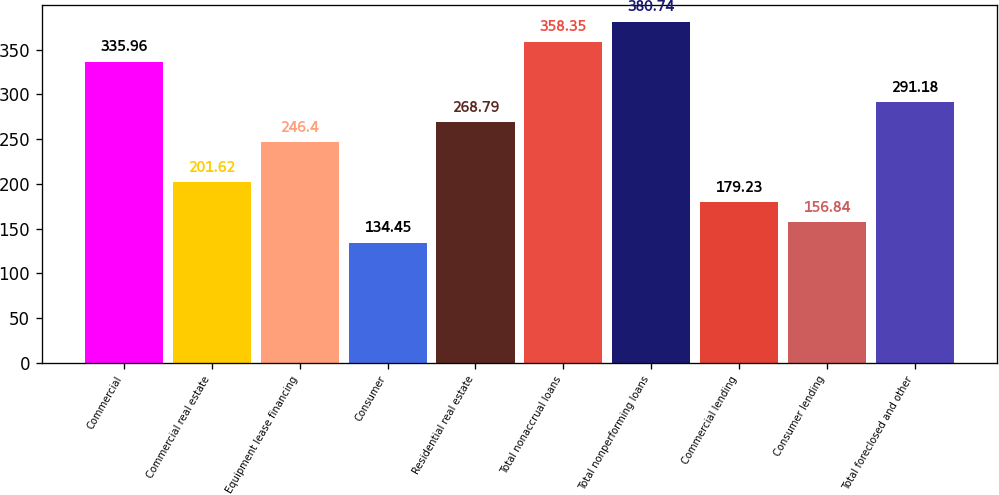<chart> <loc_0><loc_0><loc_500><loc_500><bar_chart><fcel>Commercial<fcel>Commercial real estate<fcel>Equipment lease financing<fcel>Consumer<fcel>Residential real estate<fcel>Total nonaccrual loans<fcel>Total nonperforming loans<fcel>Commercial lending<fcel>Consumer lending<fcel>Total foreclosed and other<nl><fcel>335.96<fcel>201.62<fcel>246.4<fcel>134.45<fcel>268.79<fcel>358.35<fcel>380.74<fcel>179.23<fcel>156.84<fcel>291.18<nl></chart> 